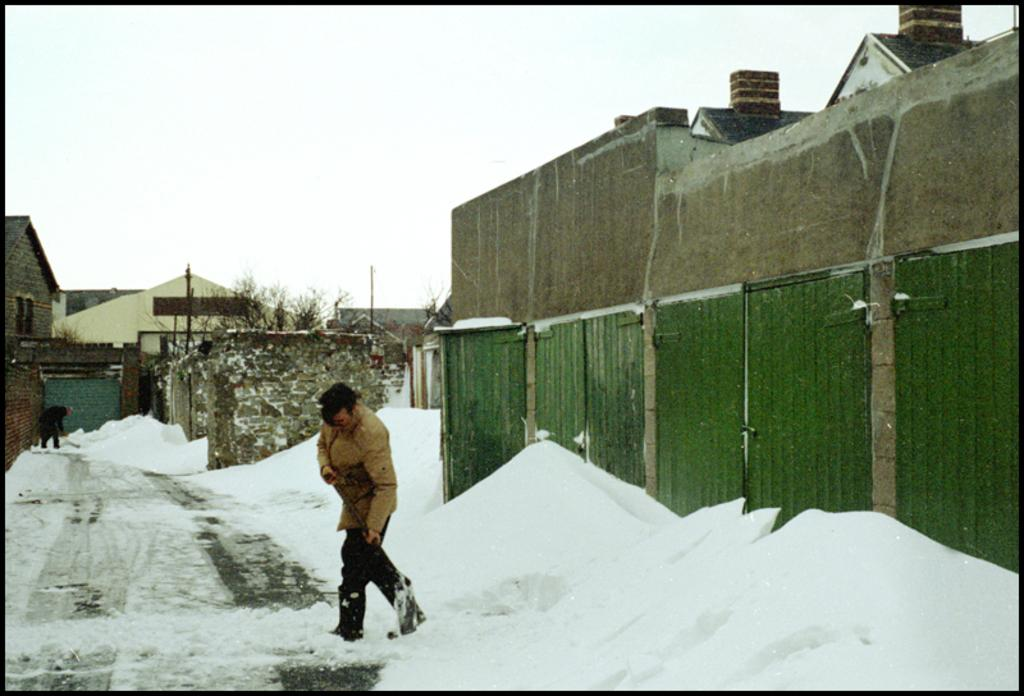What is the person in the image doing? There is a person walking in the image. What type of terrain is the person walking on? The person is walking on land. What can be seen in the foreground of the image? There are snow heaps in the image. What is visible in the background of the image? There are houses and the sky in the background of the image. What type of needle can be seen in the image? There is no needle present in the image. What kind of seed is visible in the snow heaps? There are no seeds visible in the image; it features snow heaps and a person walking. 